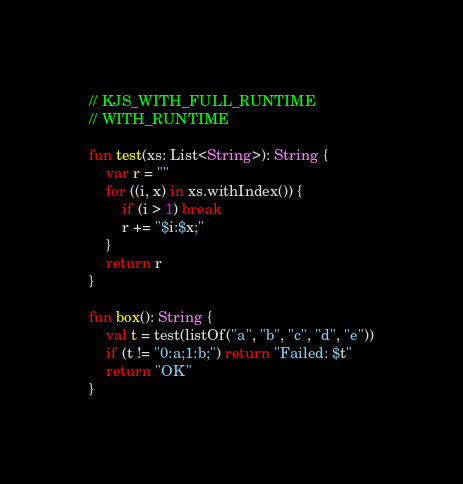Convert code to text. <code><loc_0><loc_0><loc_500><loc_500><_Kotlin_>// KJS_WITH_FULL_RUNTIME
// WITH_RUNTIME

fun test(xs: List<String>): String {
    var r = ""
    for ((i, x) in xs.withIndex()) {
        if (i > 1) break
        r += "$i:$x;"
    }
    return r
}

fun box(): String {
    val t = test(listOf("a", "b", "c", "d", "e"))
    if (t != "0:a;1:b;") return "Failed: $t"
    return "OK"
}</code> 